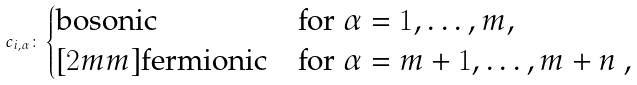<formula> <loc_0><loc_0><loc_500><loc_500>c _ { i , \alpha } \colon \begin{cases} \text {bosonic} & \text {for $\alpha= 1, \dots, m$} , \\ [ 2 m m ] \text {fermionic} & \text {for $\alpha= m+1, \dots, m+n$ ,} \end{cases}</formula> 